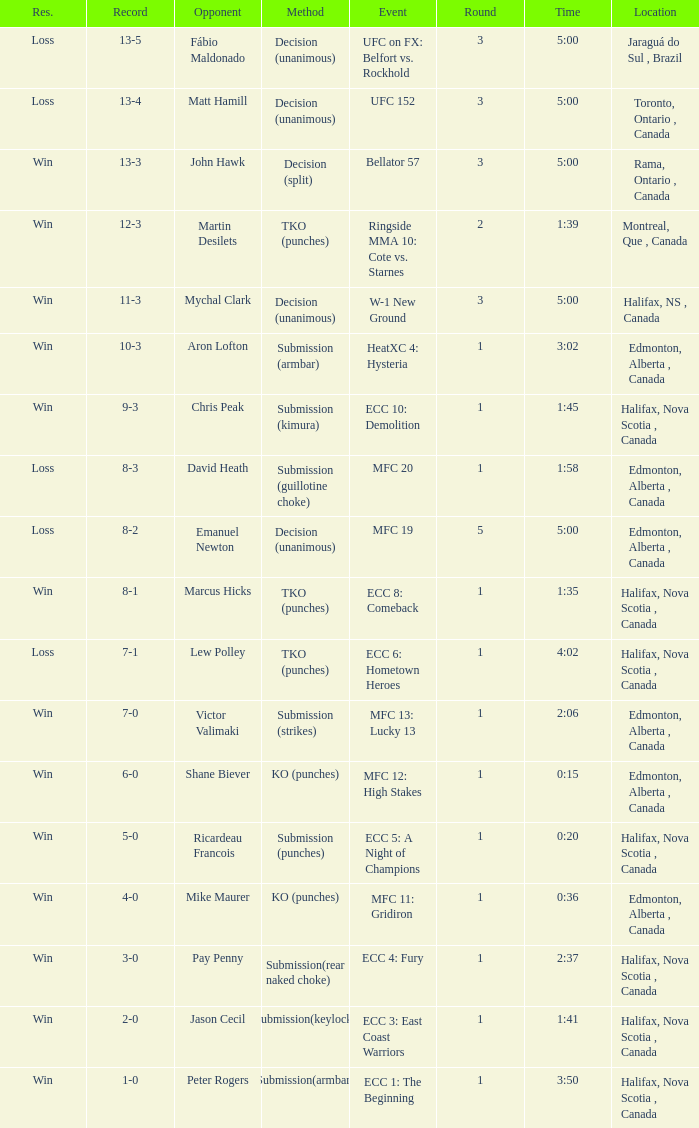Where does the ecc 8: comeback event take place in the match? Halifax, Nova Scotia , Canada. 